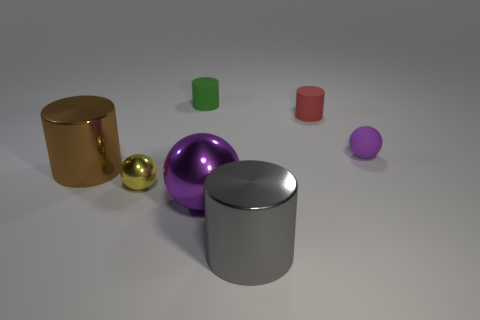If this image were part of an art installation, what theme do you think it might represent? As part of an art installation, this image could represent the theme of 'Variety in Unity', exploring how objects of different colors, sizes, and textures can coexist harmoniously within a shared space, reflecting diversity within unity. 